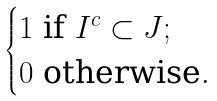<formula> <loc_0><loc_0><loc_500><loc_500>\begin{cases} 1 \text { if $I^{c}\subset J$} ; \\ 0 \text { otherwise} . \end{cases}</formula> 